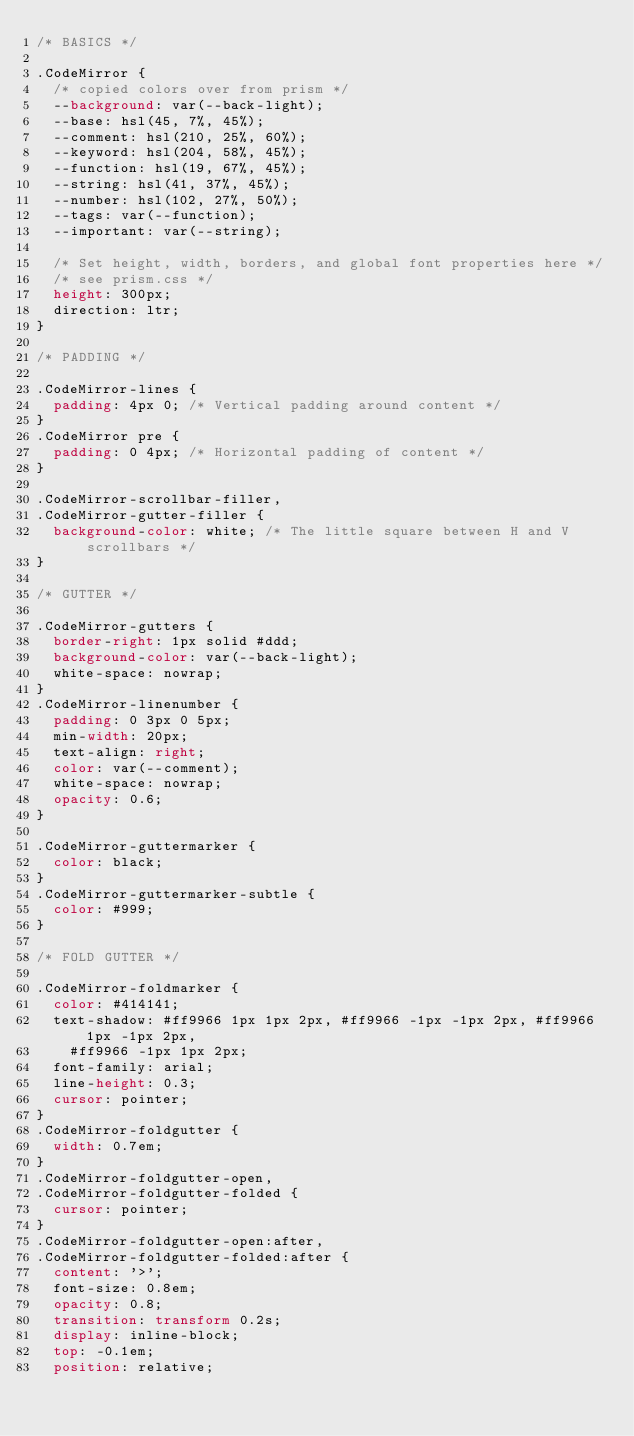<code> <loc_0><loc_0><loc_500><loc_500><_CSS_>/* BASICS */

.CodeMirror {
  /* copied colors over from prism */
  --background: var(--back-light);
  --base: hsl(45, 7%, 45%);
  --comment: hsl(210, 25%, 60%);
  --keyword: hsl(204, 58%, 45%);
  --function: hsl(19, 67%, 45%);
  --string: hsl(41, 37%, 45%);
  --number: hsl(102, 27%, 50%);
  --tags: var(--function);
  --important: var(--string);

  /* Set height, width, borders, and global font properties here */
  /* see prism.css */
  height: 300px;
  direction: ltr;
}

/* PADDING */

.CodeMirror-lines {
  padding: 4px 0; /* Vertical padding around content */
}
.CodeMirror pre {
  padding: 0 4px; /* Horizontal padding of content */
}

.CodeMirror-scrollbar-filler,
.CodeMirror-gutter-filler {
  background-color: white; /* The little square between H and V scrollbars */
}

/* GUTTER */

.CodeMirror-gutters {
  border-right: 1px solid #ddd;
  background-color: var(--back-light);
  white-space: nowrap;
}
.CodeMirror-linenumber {
  padding: 0 3px 0 5px;
  min-width: 20px;
  text-align: right;
  color: var(--comment);
  white-space: nowrap;
  opacity: 0.6;
}

.CodeMirror-guttermarker {
  color: black;
}
.CodeMirror-guttermarker-subtle {
  color: #999;
}

/* FOLD GUTTER */

.CodeMirror-foldmarker {
  color: #414141;
  text-shadow: #ff9966 1px 1px 2px, #ff9966 -1px -1px 2px, #ff9966 1px -1px 2px,
    #ff9966 -1px 1px 2px;
  font-family: arial;
  line-height: 0.3;
  cursor: pointer;
}
.CodeMirror-foldgutter {
  width: 0.7em;
}
.CodeMirror-foldgutter-open,
.CodeMirror-foldgutter-folded {
  cursor: pointer;
}
.CodeMirror-foldgutter-open:after,
.CodeMirror-foldgutter-folded:after {
  content: '>';
  font-size: 0.8em;
  opacity: 0.8;
  transition: transform 0.2s;
  display: inline-block;
  top: -0.1em;
  position: relative;</code> 